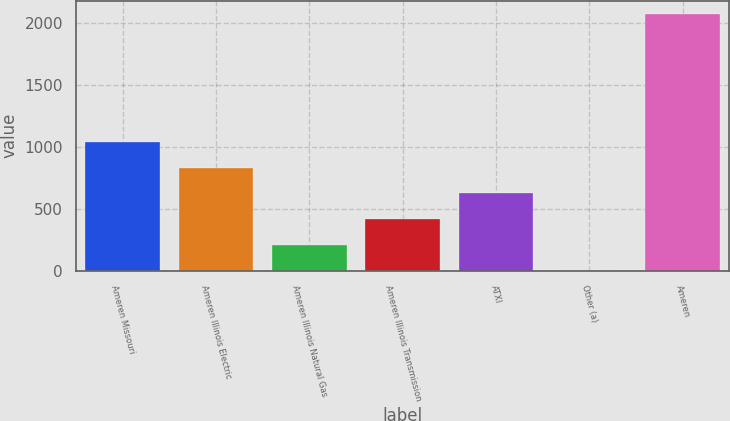Convert chart. <chart><loc_0><loc_0><loc_500><loc_500><bar_chart><fcel>Ameren Missouri<fcel>Ameren Illinois Electric<fcel>Ameren Illinois Natural Gas<fcel>Ameren Illinois Transmission<fcel>ATXI<fcel>Other (a)<fcel>Ameren<nl><fcel>1039<fcel>831.6<fcel>209.4<fcel>416.8<fcel>624.2<fcel>2<fcel>2076<nl></chart> 